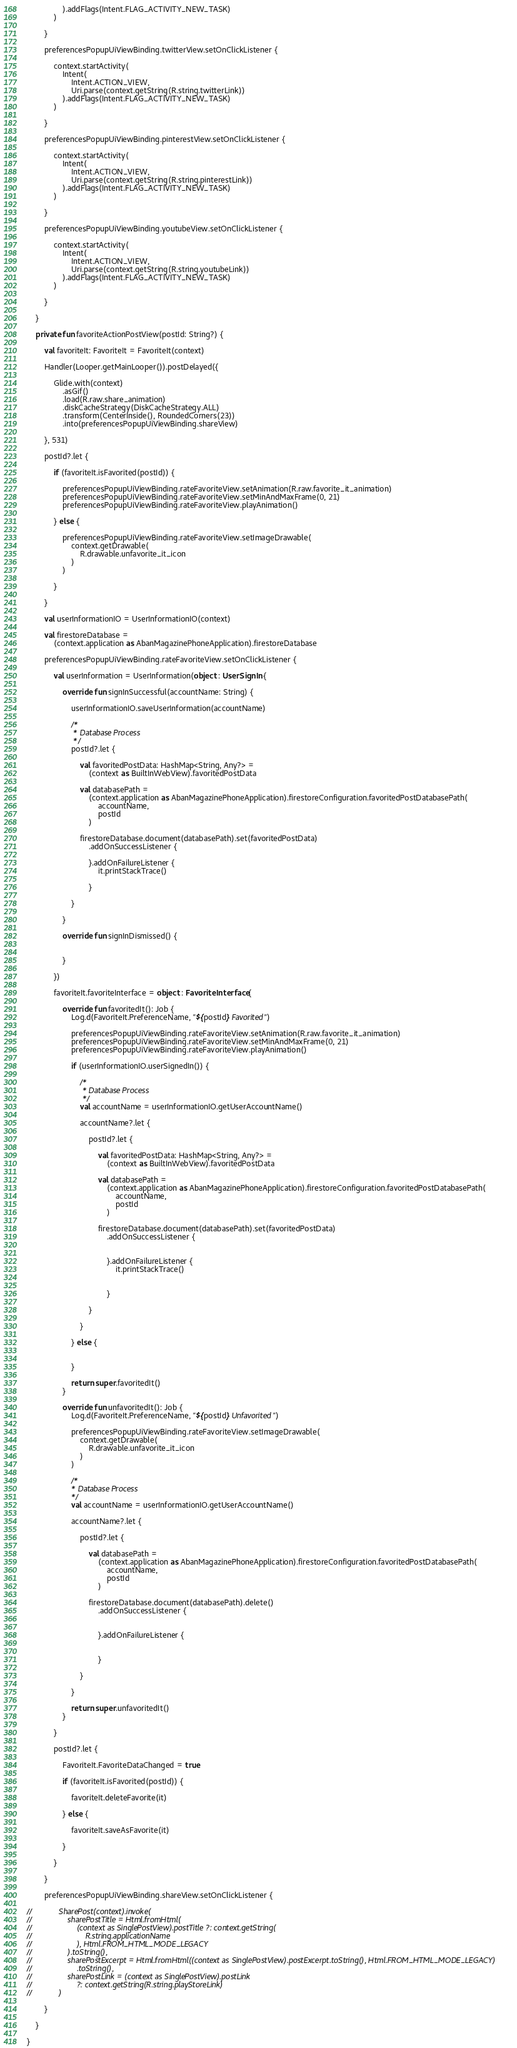Convert code to text. <code><loc_0><loc_0><loc_500><loc_500><_Kotlin_>                ).addFlags(Intent.FLAG_ACTIVITY_NEW_TASK)
            )

        }

        preferencesPopupUiViewBinding.twitterView.setOnClickListener {

            context.startActivity(
                Intent(
                    Intent.ACTION_VIEW,
                    Uri.parse(context.getString(R.string.twitterLink))
                ).addFlags(Intent.FLAG_ACTIVITY_NEW_TASK)
            )

        }

        preferencesPopupUiViewBinding.pinterestView.setOnClickListener {

            context.startActivity(
                Intent(
                    Intent.ACTION_VIEW,
                    Uri.parse(context.getString(R.string.pinterestLink))
                ).addFlags(Intent.FLAG_ACTIVITY_NEW_TASK)
            )

        }

        preferencesPopupUiViewBinding.youtubeView.setOnClickListener {

            context.startActivity(
                Intent(
                    Intent.ACTION_VIEW,
                    Uri.parse(context.getString(R.string.youtubeLink))
                ).addFlags(Intent.FLAG_ACTIVITY_NEW_TASK)
            )

        }

    }

    private fun favoriteActionPostView(postId: String?) {

        val favoriteIt: FavoriteIt = FavoriteIt(context)

        Handler(Looper.getMainLooper()).postDelayed({

            Glide.with(context)
                .asGif()
                .load(R.raw.share_animation)
                .diskCacheStrategy(DiskCacheStrategy.ALL)
                .transform(CenterInside(), RoundedCorners(23))
                .into(preferencesPopupUiViewBinding.shareView)

        }, 531)

        postId?.let {

            if (favoriteIt.isFavorited(postId)) {

                preferencesPopupUiViewBinding.rateFavoriteView.setAnimation(R.raw.favorite_it_animation)
                preferencesPopupUiViewBinding.rateFavoriteView.setMinAndMaxFrame(0, 21)
                preferencesPopupUiViewBinding.rateFavoriteView.playAnimation()

            } else {

                preferencesPopupUiViewBinding.rateFavoriteView.setImageDrawable(
                    context.getDrawable(
                        R.drawable.unfavorite_it_icon
                    )
                )

            }

        }

        val userInformationIO = UserInformationIO(context)

        val firestoreDatabase =
            (context.application as AbanMagazinePhoneApplication).firestoreDatabase

        preferencesPopupUiViewBinding.rateFavoriteView.setOnClickListener {

            val userInformation = UserInformation(object : UserSignIn {

                override fun signInSuccessful(accountName: String) {

                    userInformationIO.saveUserInformation(accountName)

                    /*
                     * Database Process
                     */
                    postId?.let {

                        val favoritedPostData: HashMap<String, Any?> =
                            (context as BuiltInWebView).favoritedPostData

                        val databasePath =
                            (context.application as AbanMagazinePhoneApplication).firestoreConfiguration.favoritedPostDatabasePath(
                                accountName,
                                postId
                            )

                        firestoreDatabase.document(databasePath).set(favoritedPostData)
                            .addOnSuccessListener {

                            }.addOnFailureListener {
                                it.printStackTrace()

                            }

                    }

                }

                override fun signInDismissed() {


                }

            })

            favoriteIt.favoriteInterface = object : FavoriteInterface {

                override fun favoritedIt(): Job {
                    Log.d(FavoriteIt.PreferenceName, "${postId} Favorited")

                    preferencesPopupUiViewBinding.rateFavoriteView.setAnimation(R.raw.favorite_it_animation)
                    preferencesPopupUiViewBinding.rateFavoriteView.setMinAndMaxFrame(0, 21)
                    preferencesPopupUiViewBinding.rateFavoriteView.playAnimation()

                    if (userInformationIO.userSignedIn()) {

                        /*
                         * Database Process
                         */
                        val accountName = userInformationIO.getUserAccountName()

                        accountName?.let {

                            postId?.let {

                                val favoritedPostData: HashMap<String, Any?> =
                                    (context as BuiltInWebView).favoritedPostData

                                val databasePath =
                                    (context.application as AbanMagazinePhoneApplication).firestoreConfiguration.favoritedPostDatabasePath(
                                        accountName,
                                        postId
                                    )

                                firestoreDatabase.document(databasePath).set(favoritedPostData)
                                    .addOnSuccessListener {


                                    }.addOnFailureListener {
                                        it.printStackTrace()


                                    }

                            }

                        }

                    } else {


                    }

                    return super.favoritedIt()
                }

                override fun unfavoritedIt(): Job {
                    Log.d(FavoriteIt.PreferenceName, "${postId} Unfavorited")

                    preferencesPopupUiViewBinding.rateFavoriteView.setImageDrawable(
                        context.getDrawable(
                            R.drawable.unfavorite_it_icon
                        )
                    )

                    /*
                    * Database Process
                    */
                    val accountName = userInformationIO.getUserAccountName()

                    accountName?.let {

                        postId?.let {

                            val databasePath =
                                (context.application as AbanMagazinePhoneApplication).firestoreConfiguration.favoritedPostDatabasePath(
                                    accountName,
                                    postId
                                )

                            firestoreDatabase.document(databasePath).delete()
                                .addOnSuccessListener {


                                }.addOnFailureListener {


                                }

                        }

                    }

                    return super.unfavoritedIt()
                }

            }

            postId?.let {

                FavoriteIt.FavoriteDataChanged = true

                if (favoriteIt.isFavorited(postId)) {

                    favoriteIt.deleteFavorite(it)

                } else {

                    favoriteIt.saveAsFavorite(it)

                }

            }

        }

        preferencesPopupUiViewBinding.shareView.setOnClickListener {

//            SharePost(context).invoke(
//                sharePostTitle = Html.fromHtml(
//                    (context as SinglePostView).postTitle ?: context.getString(
//                        R.string.applicationName
//                    ), Html.FROM_HTML_MODE_LEGACY
//                ).toString(),
//                sharePostExcerpt = Html.fromHtml((context as SinglePostView).postExcerpt.toString(), Html.FROM_HTML_MODE_LEGACY)
//                    .toString(),
//                sharePostLink = (context as SinglePostView).postLink
//                    ?: context.getString(R.string.playStoreLink)
//            )

        }

    }

}</code> 